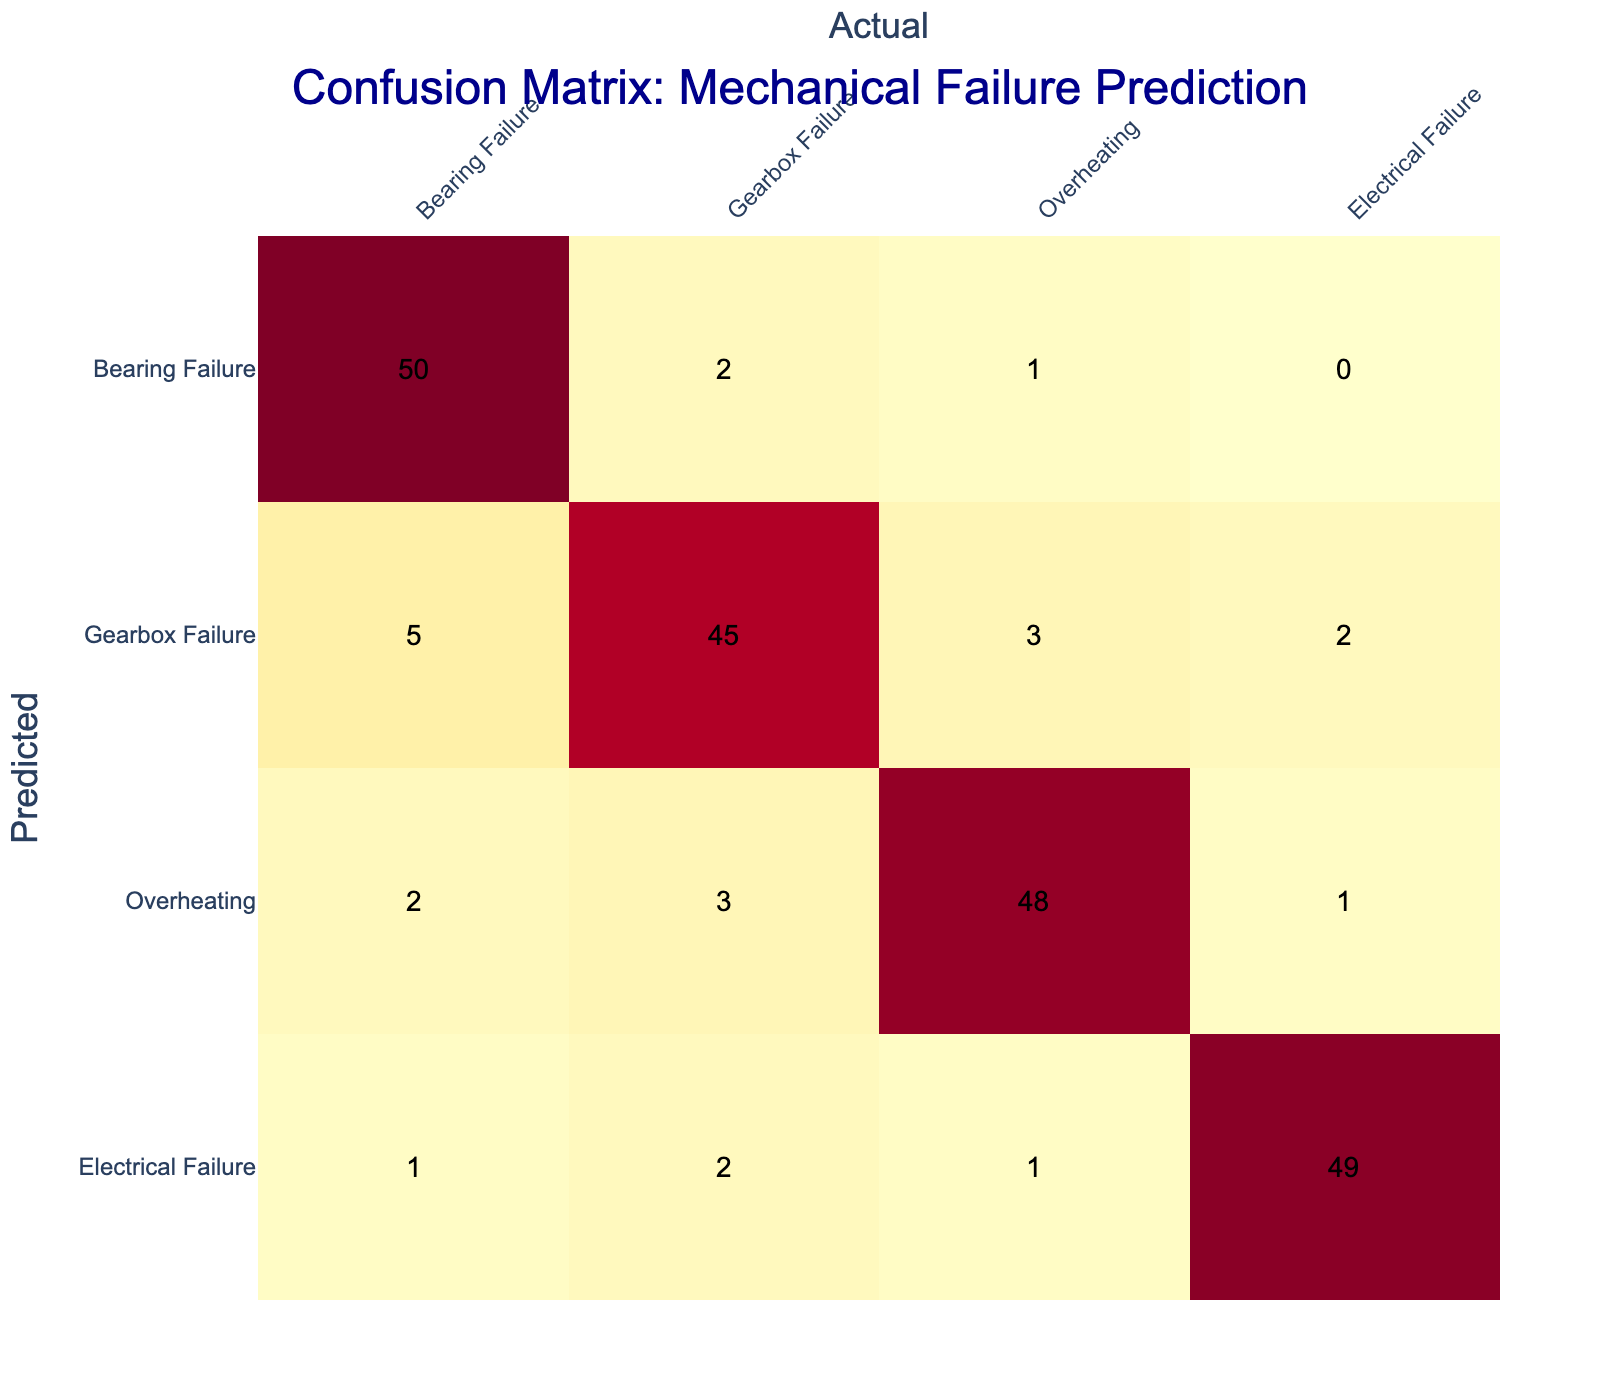What is the predicted count of bearing failures correctly identified as bearing failures? Referring to the confusion matrix, the cell where the predicted category is "Bearing Failure" and the actual category is also "Bearing Failure" indicates the correct predictions. The value in that cell is 50.
Answer: 50 What is the total number of gearbox failures predicted? To find the total predicted gearbox failures, sum the values in the "Gearbox Failure" row: 5 (predicted as Bearing Failure) + 45 (predicted as Gearbox Failure) + 3 (predicted as Overheating) + 2 (predicted as Electrical Failure) = 55.
Answer: 55 Is the model better at predicting overheating or electrical failure? Comparing the predicted counts for Overheating (2 as Bearing Failure, 3 as Gearbox Failure, 48 as Overheating, and 1 as Electrical Failure) with Electrical Failure (1 as Bearing Failure, 2 as Gearbox Failure, 1 as Overheating, and 49 as Electrical Failure), the total predicted values are 54 for Overheating and 53 for Electrical Failure, indicating that the model is slightly better at predicting Overheating.
Answer: Yes, it is better at predicting overheating What is the precision for predicting electrical failures? Precision is calculated as true positives divided by the sum of true positives and false positives. The true positives for Electrical Failure are 49, and the false positives (predicted incorrectly as Electrical Failure) are 0+2+1 = 3. Thus, precision = 49 / (49 + 3) = 49 / 52 = 0.942 or 94.2%.
Answer: 94.2% How many total predictions were made in the confusion matrix? To find the total predictions, sum all the values in the matrix: (50 + 2 + 1 + 0) + (5 + 45 + 3 + 2) + (2 + 3 + 48 + 1) + (1 + 2 + 1 + 49) = 50 + 2 + 1 + 0 + 5 + 45 + 3 + 2 + 2 + 3 + 48 + 1 + 1 + 2 + 1 + 49 = 232.
Answer: 232 What is the recall for predicting bearing failures? Recall is calculated as true positives divided by the sum of true positives and false negatives. The true positives for Bearing Failure are 50, and the false negatives (actual Bearing Failures predicted incorrectly as other classes) are 2 + 1 + 0 + 1 = 4. Thus, recall = 50 / (50 + 4) = 50 / 54 ≈ 0.926 or 92.6%.
Answer: 92.6% 